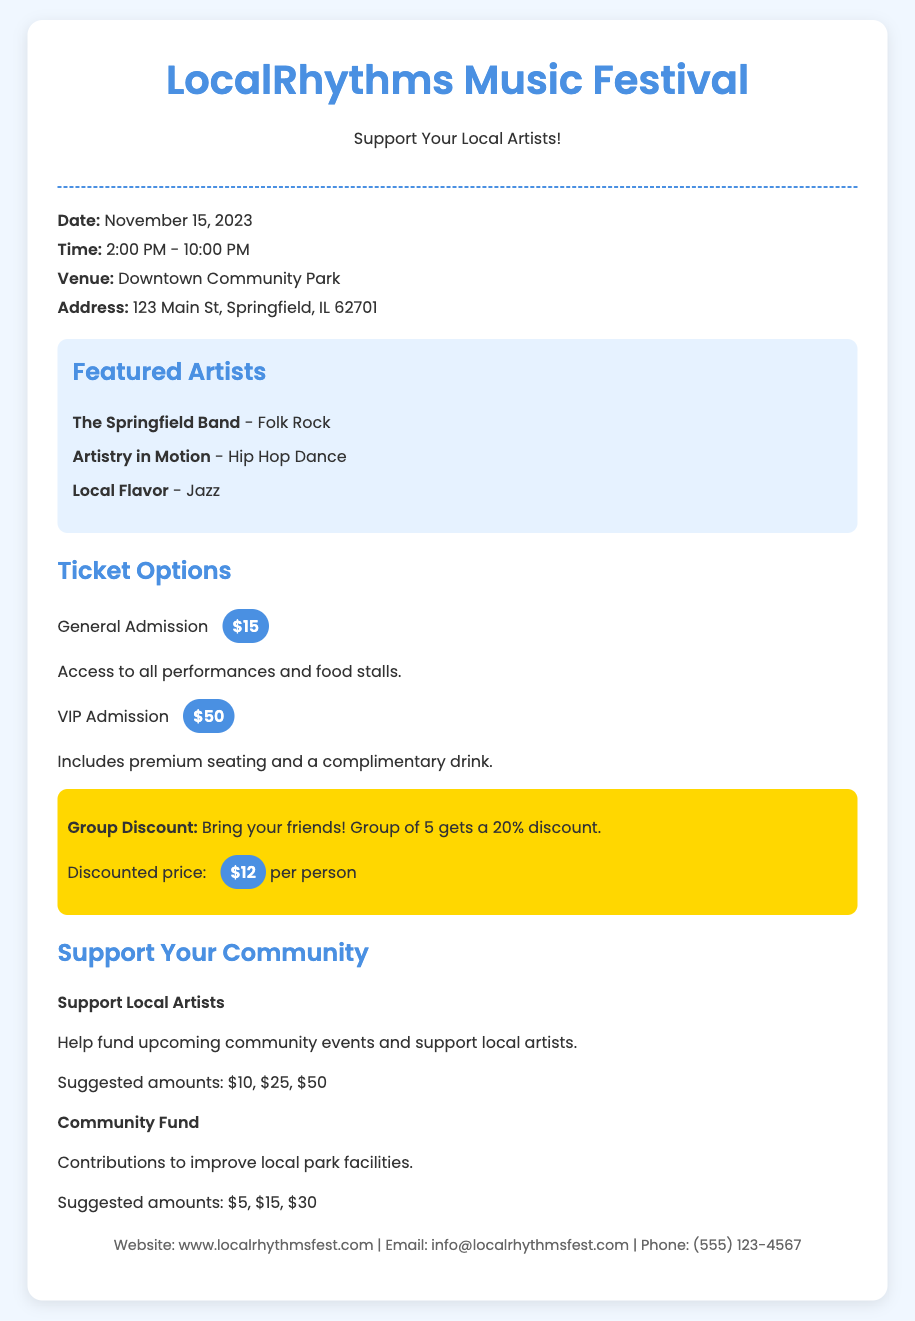What is the date of the event? The date of the event is prominently mentioned in the event-info section of the document.
Answer: November 15, 2023 What are the ticket prices for General Admission and VIP Admission? The ticket prices are provided under the ticket-options section, detailing both types of admission.
Answer: $15 and $50 What is the location of the festival? The venue and address are specified in the event-info section, indicating where the festival will take place.
Answer: Downtown Community Park, 123 Main St, Springfield, IL 62701 How much is the group discount per person for a group of five? The group discount price is noted in the ticket-options section, highlighting the cost for each member of the group.
Answer: $12 What types of performances will happen at the festival? The types of performances are listed under the artists section, showcasing the variety of acts featured.
Answer: Folk Rock, Hip Hop Dance, Jazz What is the suggested donation amount to support local artists? This information can be found in the donation-options section, indicating how much attendees can contribute.
Answer: $10, $25, $50 How long is the festival scheduled to last? The time duration of the event is included in the event-info section, indicating the start and end times.
Answer: 8 hours What additional benefit does VIP Admission include? The benefits of VIP Admission are described in the ticket-options section, highlighting premium perks.
Answer: Premium seating and a complimentary drink What is the website for more information about the event? The website is included in the contact-info section, serving as a resource for further details.
Answer: www.localrhythmsfest.com 